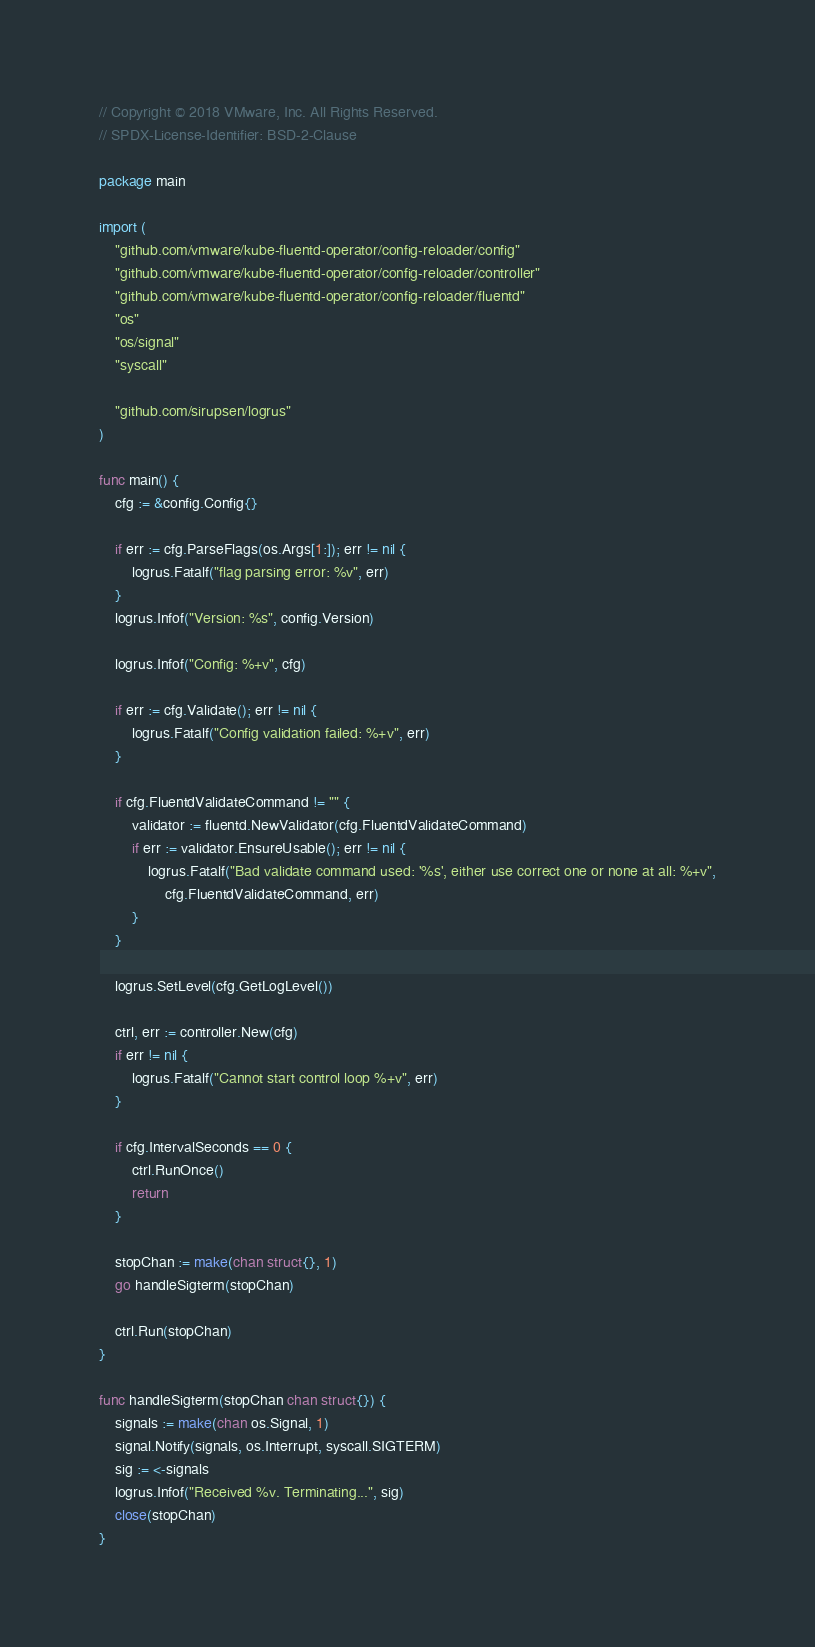<code> <loc_0><loc_0><loc_500><loc_500><_Go_>// Copyright © 2018 VMware, Inc. All Rights Reserved.
// SPDX-License-Identifier: BSD-2-Clause

package main

import (
	"github.com/vmware/kube-fluentd-operator/config-reloader/config"
	"github.com/vmware/kube-fluentd-operator/config-reloader/controller"
	"github.com/vmware/kube-fluentd-operator/config-reloader/fluentd"
	"os"
	"os/signal"
	"syscall"

	"github.com/sirupsen/logrus"
)

func main() {
	cfg := &config.Config{}

	if err := cfg.ParseFlags(os.Args[1:]); err != nil {
		logrus.Fatalf("flag parsing error: %v", err)
	}
	logrus.Infof("Version: %s", config.Version)

	logrus.Infof("Config: %+v", cfg)

	if err := cfg.Validate(); err != nil {
		logrus.Fatalf("Config validation failed: %+v", err)
	}

	if cfg.FluentdValidateCommand != "" {
		validator := fluentd.NewValidator(cfg.FluentdValidateCommand)
		if err := validator.EnsureUsable(); err != nil {
			logrus.Fatalf("Bad validate command used: '%s', either use correct one or none at all: %+v",
				cfg.FluentdValidateCommand, err)
		}
	}

	logrus.SetLevel(cfg.GetLogLevel())

	ctrl, err := controller.New(cfg)
	if err != nil {
		logrus.Fatalf("Cannot start control loop %+v", err)
	}

	if cfg.IntervalSeconds == 0 {
		ctrl.RunOnce()
		return
	}

	stopChan := make(chan struct{}, 1)
	go handleSigterm(stopChan)

	ctrl.Run(stopChan)
}

func handleSigterm(stopChan chan struct{}) {
	signals := make(chan os.Signal, 1)
	signal.Notify(signals, os.Interrupt, syscall.SIGTERM)
	sig := <-signals
	logrus.Infof("Received %v. Terminating...", sig)
	close(stopChan)
}
</code> 